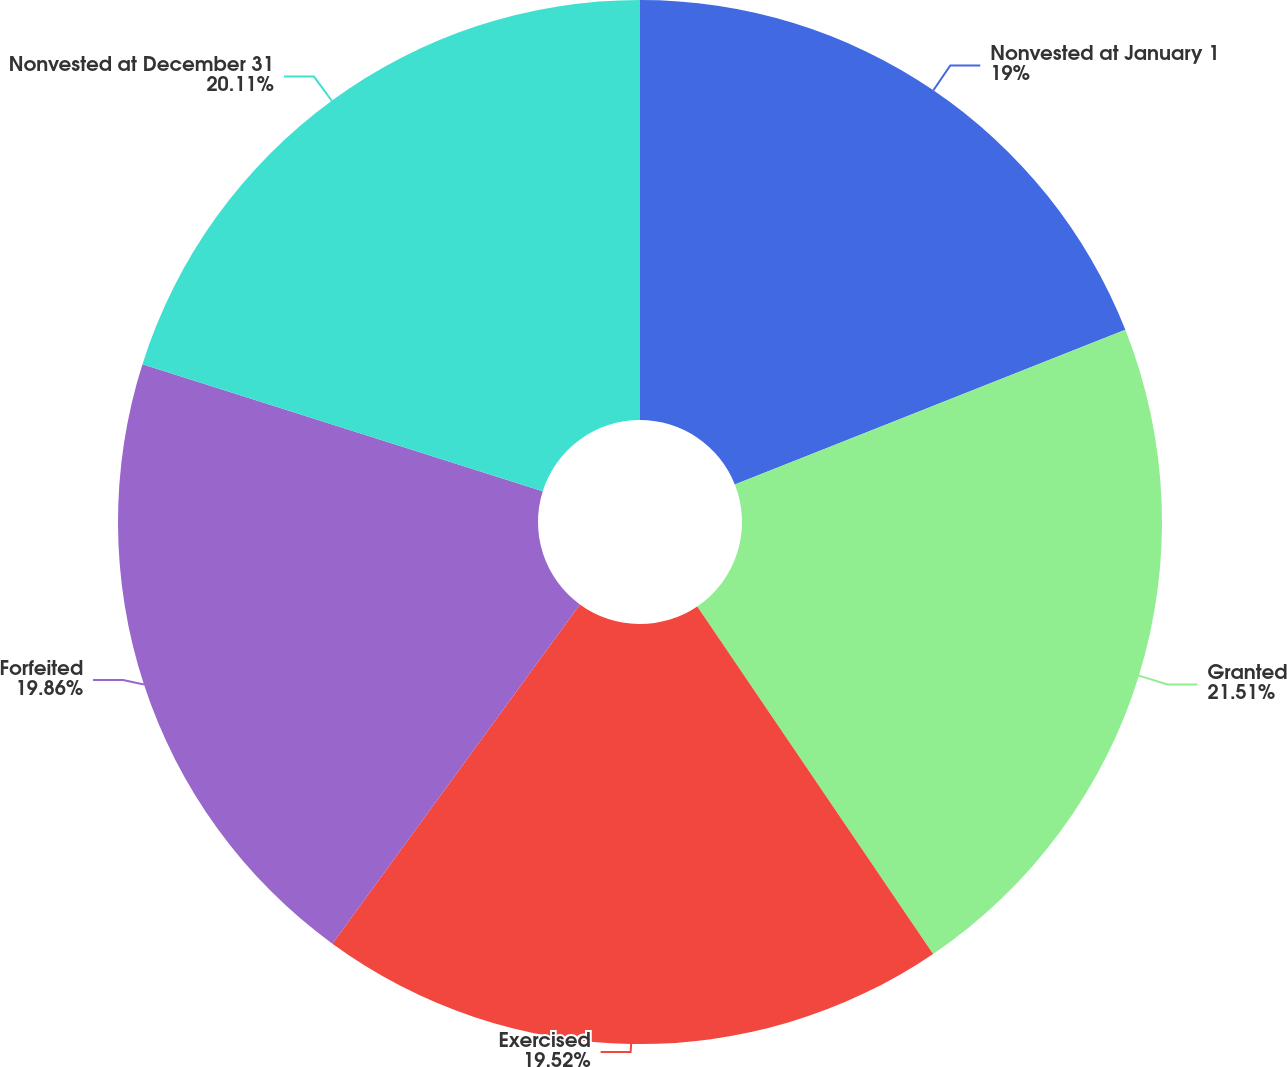Convert chart to OTSL. <chart><loc_0><loc_0><loc_500><loc_500><pie_chart><fcel>Nonvested at January 1<fcel>Granted<fcel>Exercised<fcel>Forfeited<fcel>Nonvested at December 31<nl><fcel>19.0%<fcel>21.51%<fcel>19.52%<fcel>19.86%<fcel>20.11%<nl></chart> 